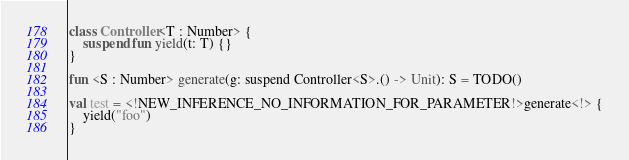Convert code to text. <code><loc_0><loc_0><loc_500><loc_500><_Kotlin_>
class Controller<T : Number> {
    suspend fun yield(t: T) {}
}

fun <S : Number> generate(g: suspend Controller<S>.() -> Unit): S = TODO()

val test = <!NEW_INFERENCE_NO_INFORMATION_FOR_PARAMETER!>generate<!> {
    yield("foo")
}
</code> 